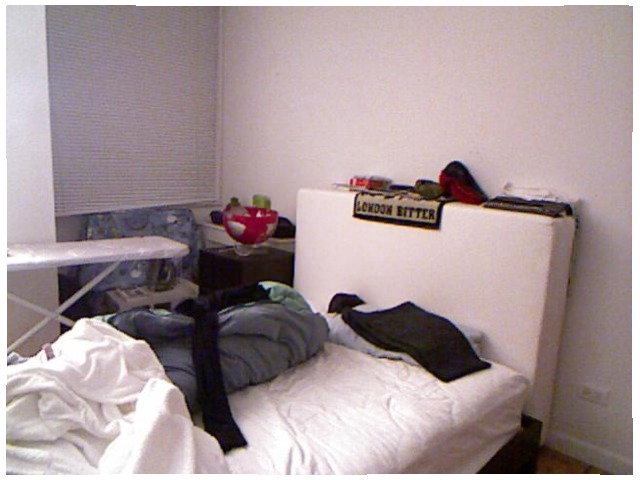<image>
Can you confirm if the iron is on the ironing board? No. The iron is not positioned on the ironing board. They may be near each other, but the iron is not supported by or resting on top of the ironing board. Is there a bed under the pants? Yes. The bed is positioned underneath the pants, with the pants above it in the vertical space. Is the bed under the window? No. The bed is not positioned under the window. The vertical relationship between these objects is different. 